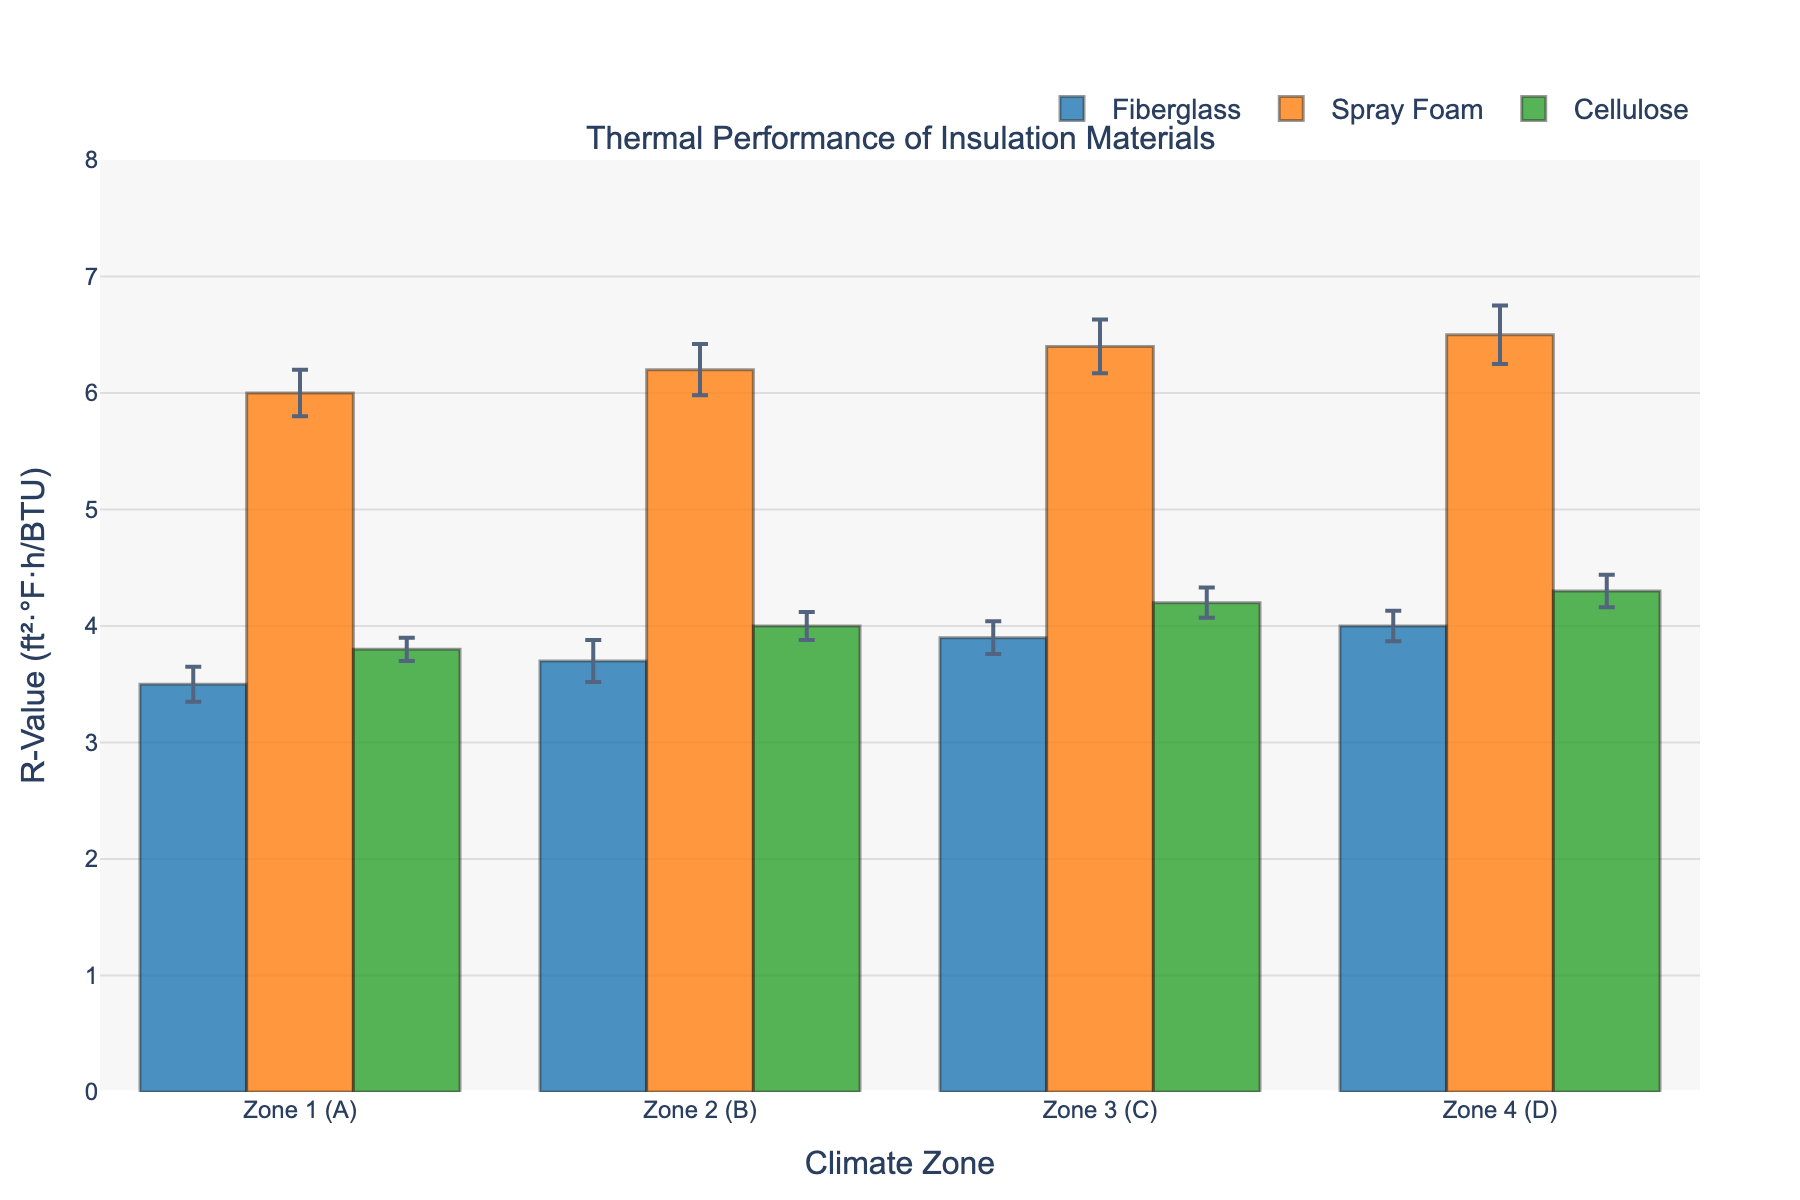What is the title of the plot? The title of the plot is usually displayed at the top of the graph. In this case, the subplot_titles parameter is set to "Thermal Performance of Insulation Materials".
Answer: Thermal Performance of Insulation Materials Which insulation material performs the best in Zone 4 (D)? By examining the bars representing each insulation material in Zone 4 (D), we see that Spray Foam has the highest mean R-Value compared to Fiberglass and Cellulose.
Answer: Spray Foam What is the range of the y-axis? The range of the y-axis is set to display values from 0 to 8, as defined in the `fig.update_yaxes(range=[0, 8])` parameter.
Answer: 0 to 8 How does the mean R-Value of Fiberglass in Zone 1 (A) compare to Zone 4 (D)? The mean R-Value of Fiberglass in Zone 1 (A) is 3.5, and in Zone 4 (D) it is 4.0. To find the difference, subtract 3.5 from 4.0.
Answer: 0.5 higher Which climate zone shows the smallest fluctuation in R-Values for Fiberglass? The fluctuation in R-Values can be inferred by looking at the error bars. The smallest error bar for Fiberglass indicates the smallest fluctuation. Zone 4 (D) shows the smallest error bar for Fiberglass.
Answer: Zone 4 (D) Compare the insulation performance of Cellulose across all climate zones. Which has the highest mean R-Value? By examining the height of the bars for Cellulose across all climate zones, Zone 4 (D) has the highest mean R-Value of 4.3.
Answer: Zone 4 (D) What is the mean R-Value for Spray Foam in Zone 2 (B)? Looking at the height of the bar for Spray Foam in Zone 2 (B), the mean R-Value is given directly by the data and is 6.2.
Answer: 6.2 How wide are the error bars for Spray Foam in Zone 3 (C)? The width of the error bars corresponds to the standard deviation. In Zone 3 (C), the standard deviation for Spray Foam is 0.23, so the error bar extends ±0.23 units above and below the mean value.
Answer: ±0.23 In which climate zone does Cellulose show the smallest mean R-Value? By inspecting the height of the bars representing Cellulose, Zone 1 (A) has the smallest mean R-Value of 3.8.
Answer: Zone 1 (A) What is the total mean R-Value of Fiberglass across all climate zones? Sum the mean R-Values of Fiberglass across all zones: 3.5 (Zone 1) + 3.7 (Zone 2) + 3.9 (Zone 3) + 4.0 (Zone 4). The total is 15.1.
Answer: 15.1 